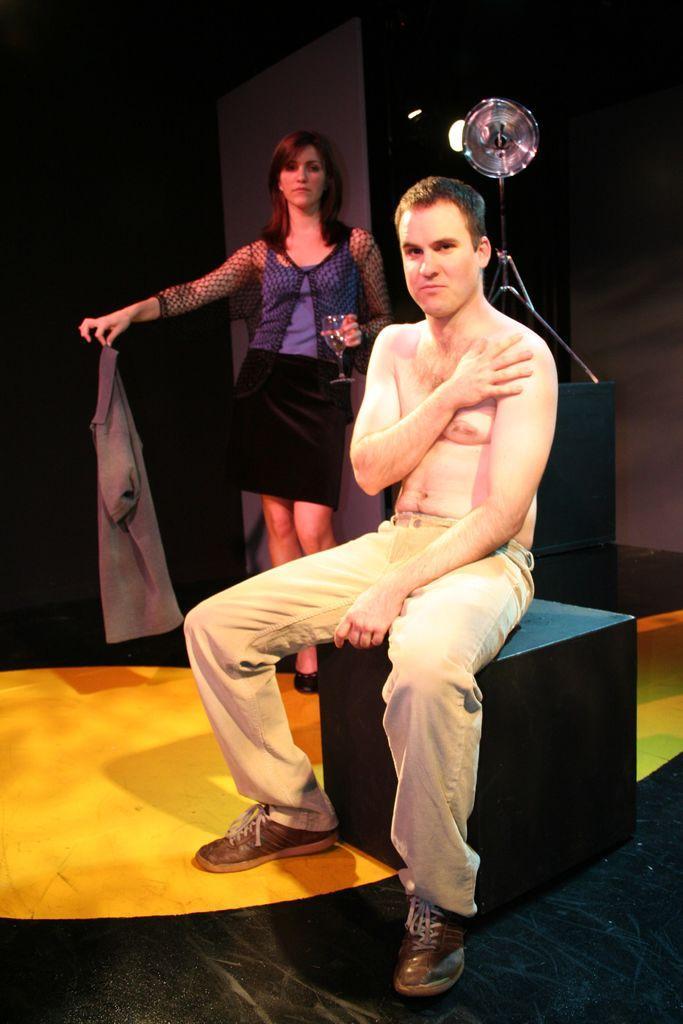Could you give a brief overview of what you see in this image? In this image there is one person who is sitting on a box, and in the background there is one woman who is holding a cloth and light, wall and some objects. At the bottom there is floor. 